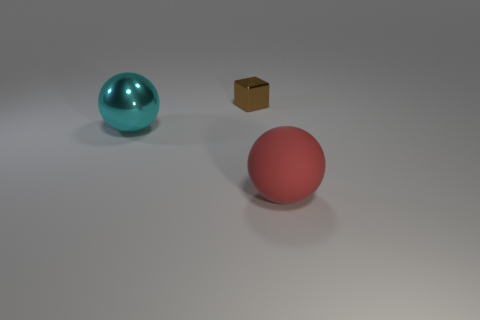How many shiny objects are big red things or tiny blue balls?
Your answer should be compact. 0. Does the red sphere have the same material as the brown object?
Offer a very short reply. No. There is a small shiny object behind the red rubber object; what is its shape?
Your answer should be very brief. Cube. Is there a red rubber sphere that is behind the big object that is to the right of the small brown object?
Provide a short and direct response. No. Is there a red shiny ball of the same size as the brown object?
Ensure brevity in your answer.  No. How big is the shiny sphere?
Provide a short and direct response. Large. What is the size of the metal object that is behind the big thing on the left side of the large red matte object?
Your answer should be compact. Small. How many tiny red matte balls are there?
Provide a succinct answer. 0. How many cyan balls are made of the same material as the brown thing?
Your answer should be compact. 1. There is a cyan thing that is the same shape as the red rubber object; what is its size?
Your answer should be compact. Large. 